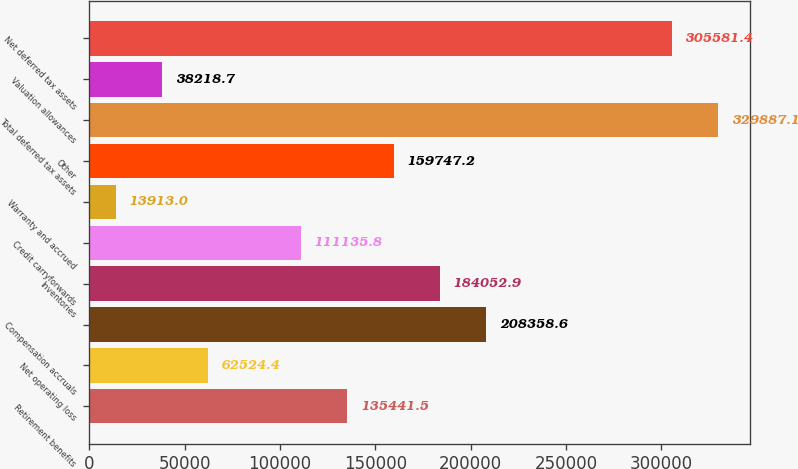Convert chart to OTSL. <chart><loc_0><loc_0><loc_500><loc_500><bar_chart><fcel>Retirement benefits<fcel>Net operating loss<fcel>Compensation accruals<fcel>Inventories<fcel>Credit carryforwards<fcel>Warranty and accrued<fcel>Other<fcel>Total deferred tax assets<fcel>Valuation allowances<fcel>Net deferred tax assets<nl><fcel>135442<fcel>62524.4<fcel>208359<fcel>184053<fcel>111136<fcel>13913<fcel>159747<fcel>329887<fcel>38218.7<fcel>305581<nl></chart> 